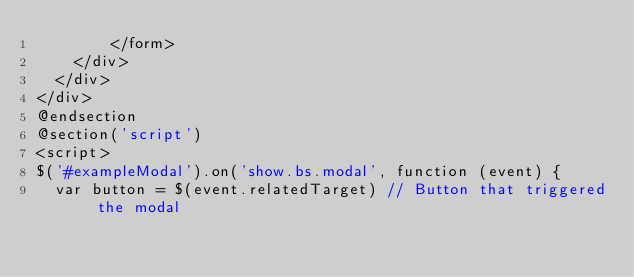<code> <loc_0><loc_0><loc_500><loc_500><_PHP_>        </form>
    </div>
  </div>
</div>
@endsection
@section('script')
<script>
$('#exampleModal').on('show.bs.modal', function (event) {
  var button = $(event.relatedTarget) // Button that triggered the modal</code> 